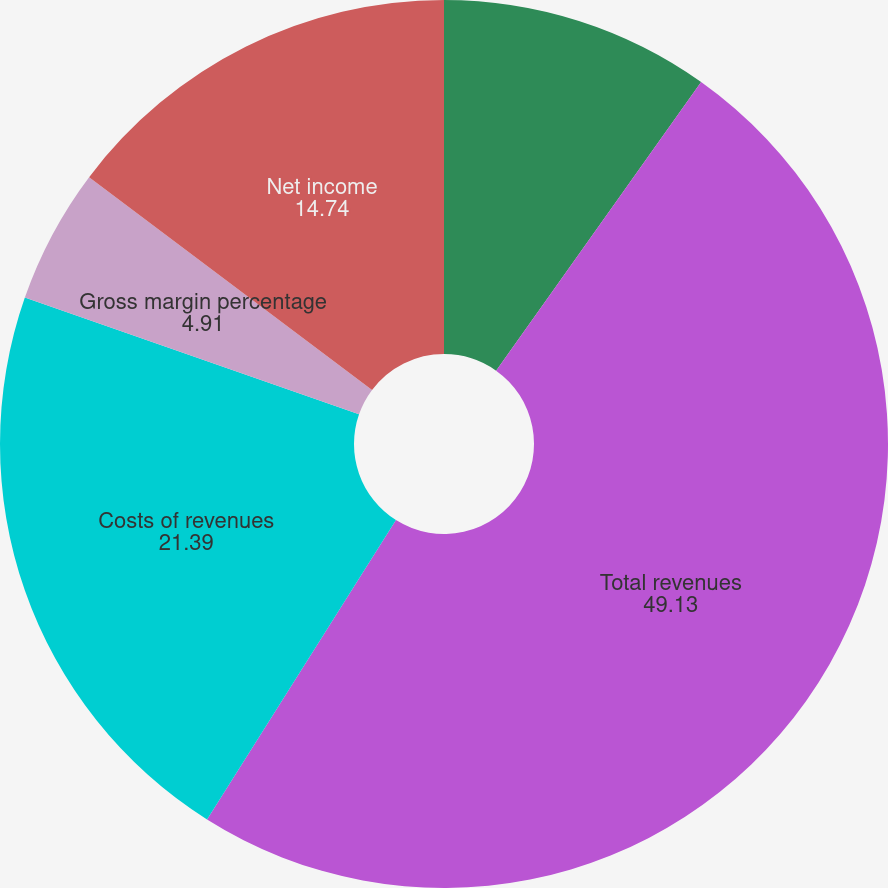Convert chart to OTSL. <chart><loc_0><loc_0><loc_500><loc_500><pie_chart><fcel>(Dollar amounts in thousands)<fcel>Total revenues<fcel>Costs of revenues<fcel>Gross margin percentage<fcel>Net income<fcel>Diluted income per share<nl><fcel>9.83%<fcel>49.13%<fcel>21.39%<fcel>4.91%<fcel>14.74%<fcel>0.0%<nl></chart> 